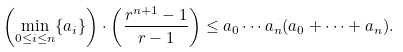Convert formula to latex. <formula><loc_0><loc_0><loc_500><loc_500>\left ( \min _ { 0 \leq i \leq n } \{ a _ { i } \} \right ) \cdot \left ( \frac { r ^ { n + 1 } - 1 } { r - 1 } \right ) \leq a _ { 0 } \cdots a _ { n } ( a _ { 0 } + \cdots + a _ { n } ) .</formula> 